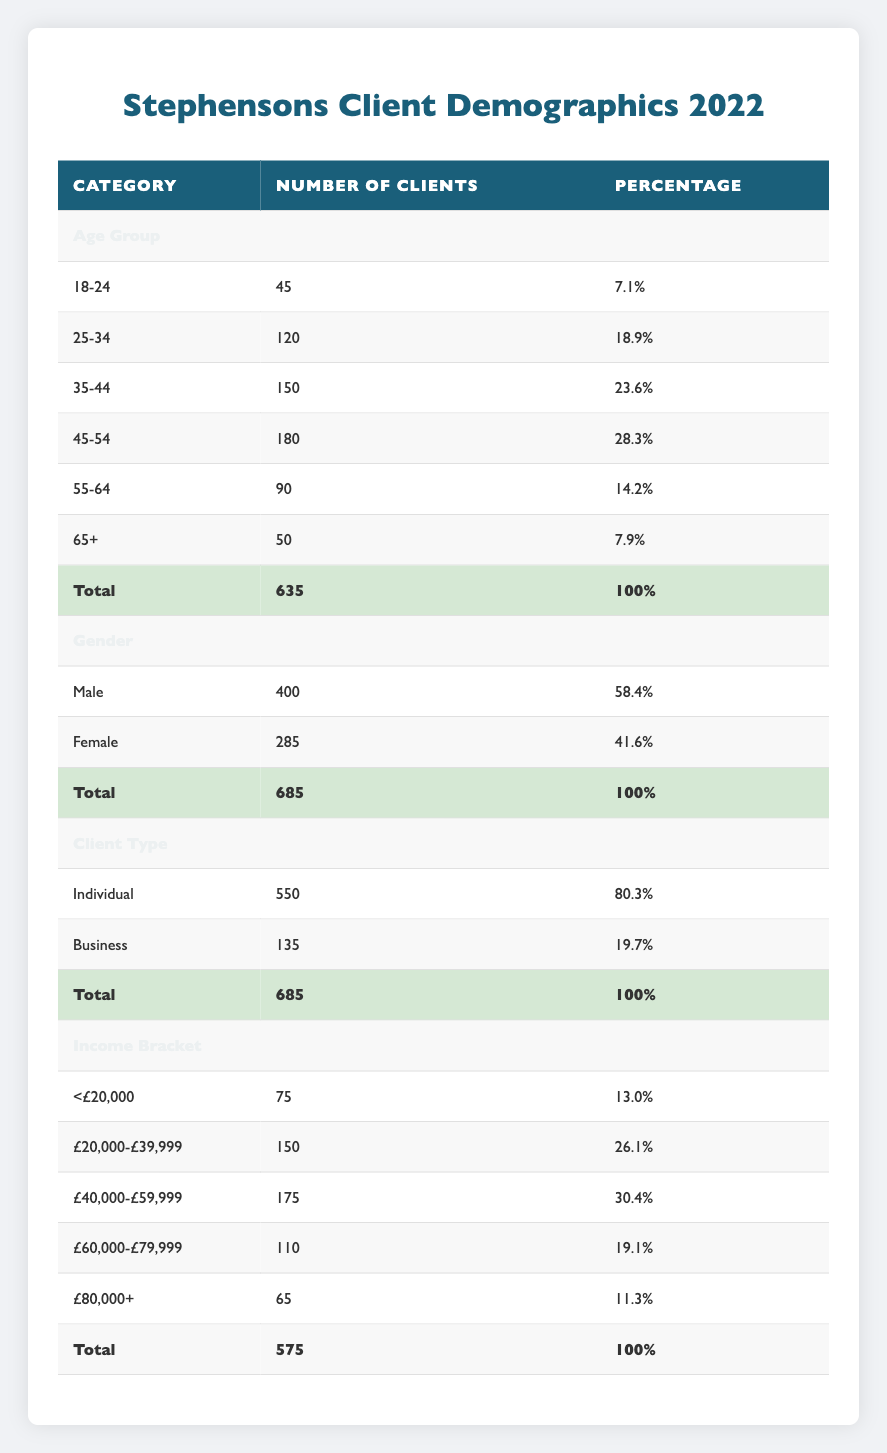What is the number of clients aged 45-54? The table shows the number of clients in different age groups. Looking specifically at the age group "45-54," we find that there were 180 clients in this category.
Answer: 180 What percentage of clients are male? The gender section of the table indicates that there are 400 male clients out of a total of 685 clients. To find the percentage, we calculate (400/685) * 100, which equals approximately 58.4%.
Answer: 58.4% What is the total number of clients in the age group of 18-24 and 65+ combined? For the age groups, we find 45 clients in the "18-24" group and 50 clients in the "65+" group. Adding these two numbers together gives us 45 + 50 = 95 clients in total for these age groups.
Answer: 95 Are there more clients under £20,000 income bracket than in the £80,000+ bracket? According to the table, there are 75 clients in the "<£20,000" income bracket and 65 clients in the "£80,000+" bracket. Since 75 is greater than 65, the statement is true.
Answer: Yes What is the difference in the number of clients between the "45-54" age group and the "25-34" age group? From the table, the "45-54" age group has 180 clients, and the "25-34" age group has 120 clients. The difference can be calculated as 180 - 120 = 60. Thus, there are 60 more clients in the "45-54" group than in the "25-34" group.
Answer: 60 What proportion of the clients are Business clients? The client type section shows that there are 135 Business clients out of a total of 685 clients. To find the proportion, we calculate 135/685, which is approximately 0.197 or 19.7%.
Answer: 19.7% How many clients are there in the income bracket of £40,000-£59,999? Referring to the income bracket section of the table, there are 175 clients in the "£40,000-£59,999" income bracket.
Answer: 175 What percentage of clients belong to the individual client type? The table states that there are 550 Individual clients out of a total of 685. The percentage is calculated as (550/685) * 100, which equals approximately 80.3%.
Answer: 80.3% 